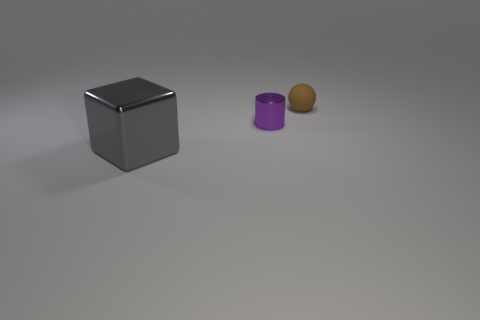There is a large metallic object; what number of small matte spheres are on the left side of it?
Give a very brief answer. 0. What is the size of the cylinder?
Give a very brief answer. Small. There is another object that is the same material as the purple object; what color is it?
Make the answer very short. Gray. How many cylinders have the same size as the gray shiny thing?
Make the answer very short. 0. Does the tiny thing in front of the small rubber sphere have the same material as the brown ball?
Provide a succinct answer. No. Are there fewer small metallic cylinders right of the brown thing than small balls?
Give a very brief answer. Yes. There is a metallic thing behind the large thing; what is its shape?
Offer a terse response. Cylinder. There is a brown rubber object that is the same size as the metal cylinder; what is its shape?
Provide a short and direct response. Sphere. Are there any other small purple things of the same shape as the small purple object?
Keep it short and to the point. No. Do the small object on the left side of the sphere and the metal thing that is in front of the tiny shiny cylinder have the same shape?
Offer a terse response. No. 